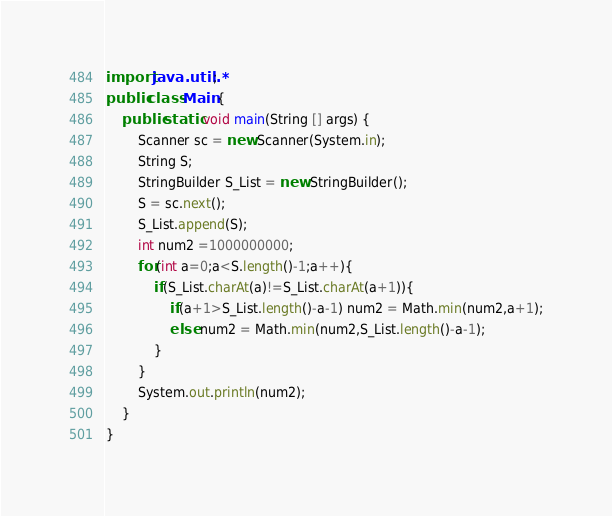<code> <loc_0><loc_0><loc_500><loc_500><_Java_>import java.util.*;
public class Main {
    public static void main(String [] args) {
        Scanner sc = new Scanner(System.in);
        String S;
        StringBuilder S_List = new StringBuilder();
        S = sc.next();
        S_List.append(S);
        int num2 =1000000000;
        for(int a=0;a<S.length()-1;a++){
            if(S_List.charAt(a)!=S_List.charAt(a+1)){
                if(a+1>S_List.length()-a-1) num2 = Math.min(num2,a+1);
                else num2 = Math.min(num2,S_List.length()-a-1);
            }
        }
        System.out.println(num2);
    }
}
</code> 